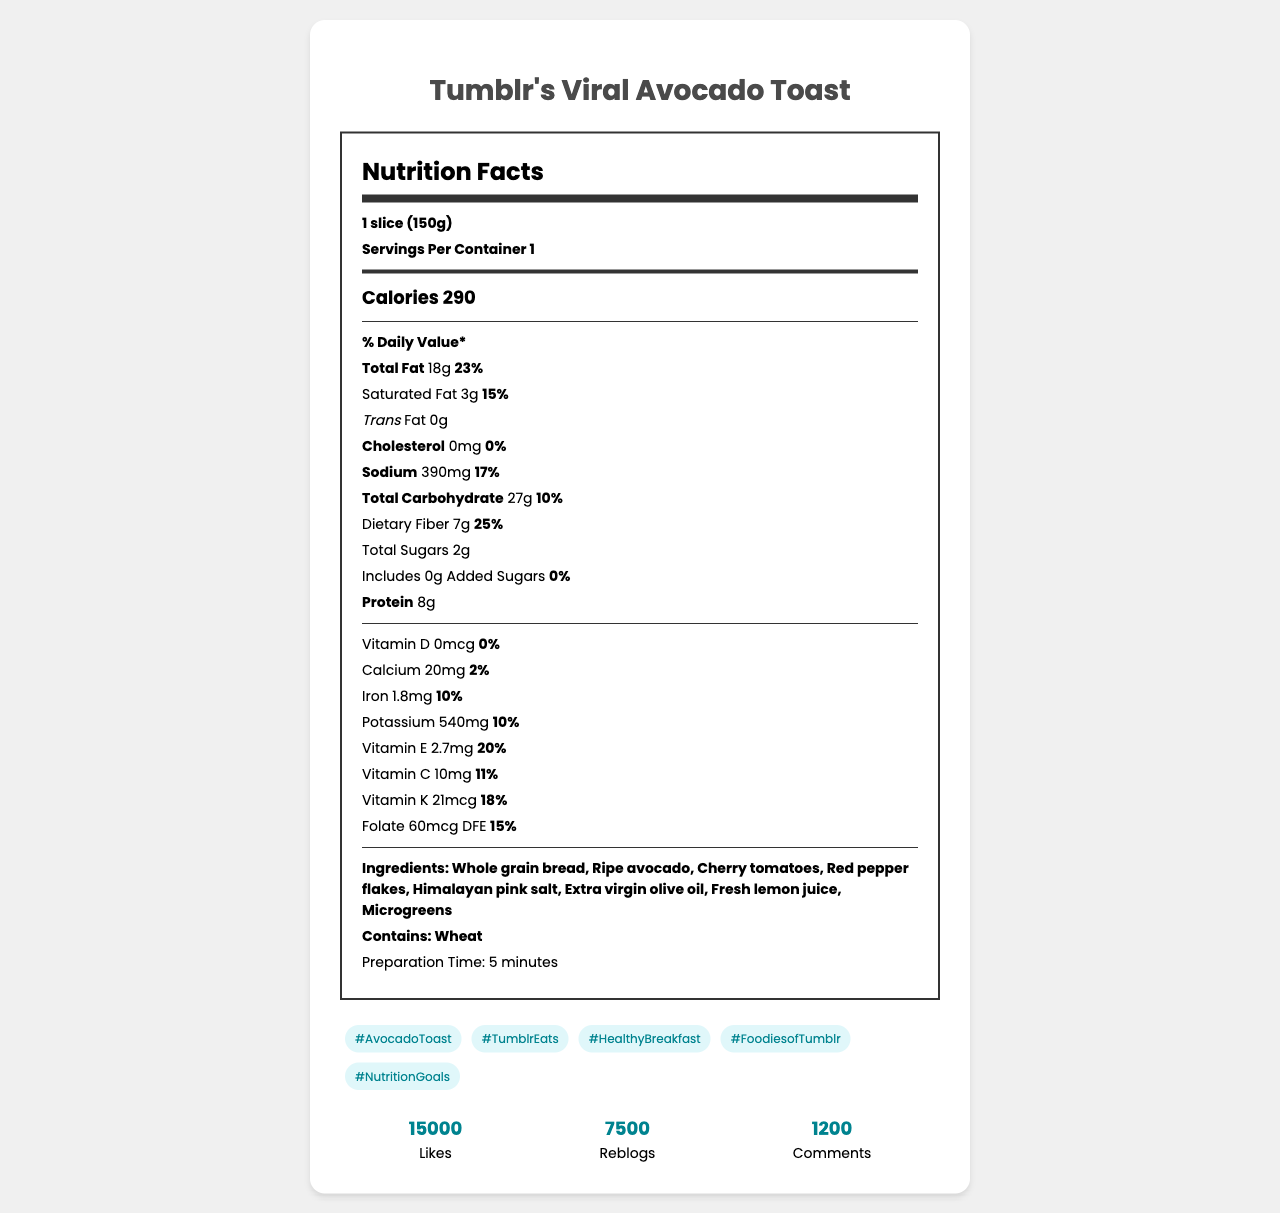What is the serving size of Tumblr's Viral Avocado Toast? The serving size is clearly listed in the document as 1 slice (150g).
Answer: 1 slice (150g) How much total fat is in the serving, and what percentage of the Daily Value does it represent? The document specifies that there are 18 grams of total fat, which is 23% of the Daily Value.
Answer: 18g, 23% Which vitamins are provided by Tumblr's Viral Avocado Toast and their Daily Values? The document lists each vitamin along with its amount and corresponding Daily Values.
Answer: Vitamin D 0%, Calcium 2%, Iron 10%, Potassium 10%, Vitamin E 20%, Vitamin C 11%, Vitamin K 18%, Folate 15% What are the main ingredients of the avocado toast? The ingredients are listed comprehensively in the document.
Answer: Whole grain bread, Ripe avocado, Cherry tomatoes, Red pepper flakes, Himalayan pink salt, Extra virgin olive oil, Fresh lemon juice, Microgreens How many calories are there in one serving of Tumblr's Viral Avocado Toast? The document states that there are 290 calories per serving.
Answer: 290 Does the avocado toast contain any added sugars? The document specifies that it includes 0 grams of added sugars.
Answer: No How much protein is in one slice of the avocado toast? The amount of protein is listed as 8 grams.
Answer: 8g What is the percentage of Daily Value for dietary fiber? The document indicates that the dietary fiber content is 7 grams, which is 25% of the Daily Value.
Answer: 25% Which of the following is a health claim made about the avocado toast? A. High in protein B. Good source of fiber C. Low in sodium D. High in vitamin D The document lists "Good source of fiber" as one of the health claims.
Answer: B. Good source of fiber Which nutrient has the highest percentage of the Daily Value? A. Vitamin C B. Folate C. Dietary Fiber D. Total Fat Dietary Fiber has a Daily Value of 25%, which is higher than the others listed.
Answer: C. Dietary Fiber Does this avocado toast contain any allergens? The document lists "Wheat" as an allergen.
Answer: Yes What is the preparation time for this recipe? The document clearly states that the preparation time is 5 minutes.
Answer: 5 minutes What hashtags are suggested for social media engagement with this recipe? The document lists these hashtags.
Answer: #AvocadoToast, #TumblrEats, #HealthyBreakfast, #FoodiesofTumblr, #NutritionGoals How many likes, reblogs, and comments does the recipe have on social media? The numbers are clearly listed in the document under social media engagement.
Answer: 15,000 likes, 7,500 reblogs, 1,200 comments Is Hippocrates a main ingredient in the avocado toast? The ingredients listed do not include Hippocrates.
Answer: No Summarize the main idea of the document. The document outlines the recipe name, serving size, nutritional content, ingredients, preparation time, social media hashtags, and engagement data, aiming to present a comprehensive overview of the avocado toast recipe for digital marketing purposes.
Answer: The document provides detailed nutrition facts, ingredient information, social media engagement metrics, and health claims for Tumblr's Viral Avocado Toast recipe, highlighting its nutritional benefits, ease of preparation, and popularity on social media platforms. How much cholesterol does the avocado toast contain? The document lists the cholesterol content as 0mg.
Answer: 0mg 